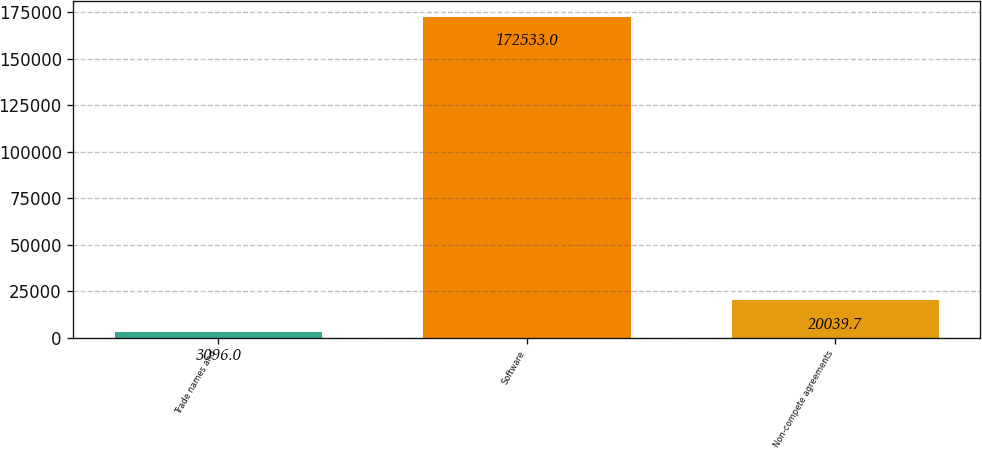<chart> <loc_0><loc_0><loc_500><loc_500><bar_chart><fcel>Trade names and<fcel>Software<fcel>Non-compete agreements<nl><fcel>3096<fcel>172533<fcel>20039.7<nl></chart> 